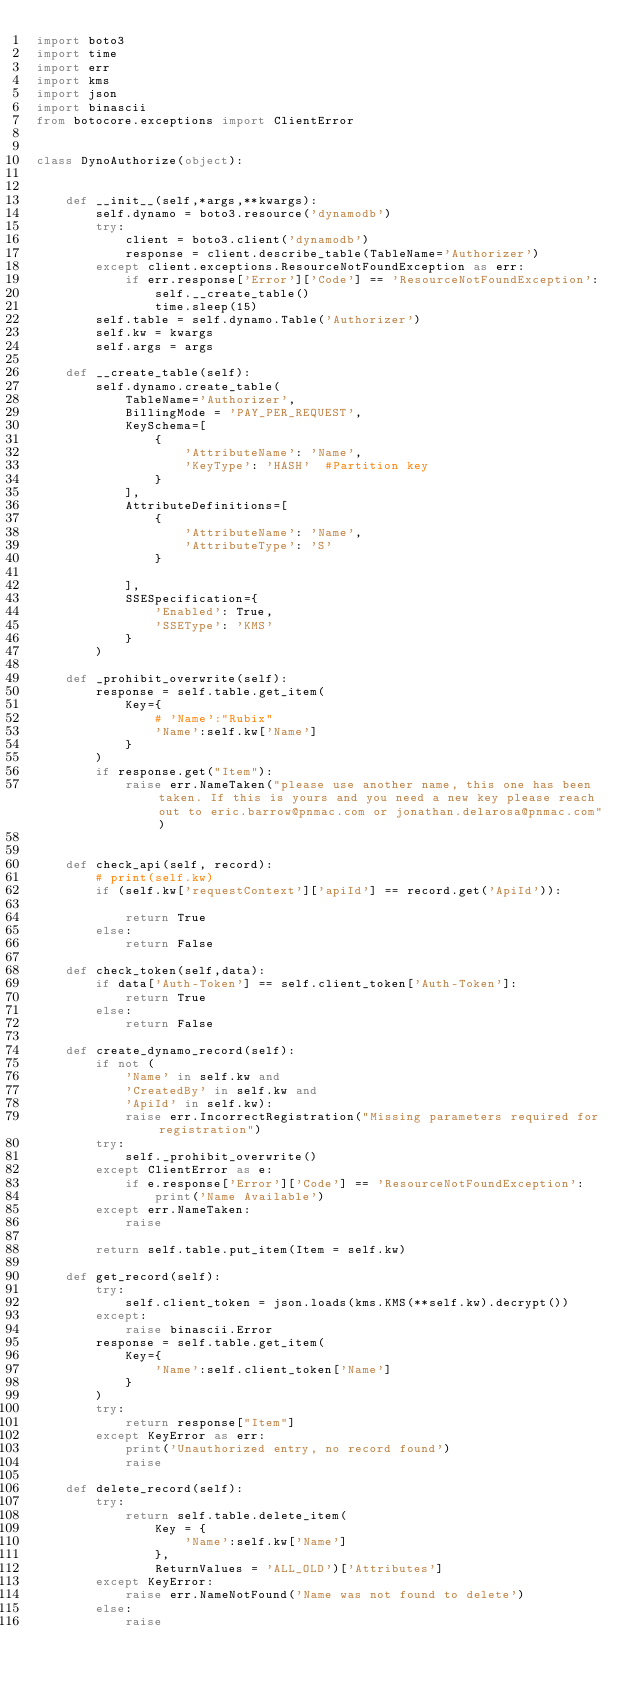Convert code to text. <code><loc_0><loc_0><loc_500><loc_500><_Python_>import boto3
import time
import err
import kms
import json
import binascii
from botocore.exceptions import ClientError


class DynoAuthorize(object):


    def __init__(self,*args,**kwargs):
        self.dynamo = boto3.resource('dynamodb')
        try:
            client = boto3.client('dynamodb')
            response = client.describe_table(TableName='Authorizer')
        except client.exceptions.ResourceNotFoundException as err:
            if err.response['Error']['Code'] == 'ResourceNotFoundException':
                self.__create_table()
                time.sleep(15)
        self.table = self.dynamo.Table('Authorizer')
        self.kw = kwargs
        self.args = args

    def __create_table(self):
        self.dynamo.create_table(
            TableName='Authorizer',
            BillingMode = 'PAY_PER_REQUEST',
            KeySchema=[
                {
                    'AttributeName': 'Name',
                    'KeyType': 'HASH'  #Partition key
                }
            ],
            AttributeDefinitions=[
                {
                    'AttributeName': 'Name',
                    'AttributeType': 'S'
                }

            ],
            SSESpecification={
                'Enabled': True,
                'SSEType': 'KMS'
            }
        )

    def _prohibit_overwrite(self):
        response = self.table.get_item(
            Key={
                # 'Name':"Rubix"
                'Name':self.kw['Name']
            }
        )
        if response.get("Item"):
            raise err.NameTaken("please use another name, this one has been taken. If this is yours and you need a new key please reach out to eric.barrow@pnmac.com or jonathan.delarosa@pnmac.com")


    def check_api(self, record):
        # print(self.kw)
        if (self.kw['requestContext']['apiId'] == record.get('ApiId')):

            return True
        else:
            return False

    def check_token(self,data):
        if data['Auth-Token'] == self.client_token['Auth-Token']:
            return True
        else:
            return False

    def create_dynamo_record(self):
        if not (
            'Name' in self.kw and
            'CreatedBy' in self.kw and
            'ApiId' in self.kw):
            raise err.IncorrectRegistration("Missing parameters required for registration")
        try:
            self._prohibit_overwrite()
        except ClientError as e:
            if e.response['Error']['Code'] == 'ResourceNotFoundException':
                print('Name Available')
        except err.NameTaken:
            raise

        return self.table.put_item(Item = self.kw)

    def get_record(self):
        try:
            self.client_token = json.loads(kms.KMS(**self.kw).decrypt())
        except:
            raise binascii.Error
        response = self.table.get_item(
            Key={
                'Name':self.client_token['Name']
            }
        )
        try:
            return response["Item"]
        except KeyError as err:
            print('Unauthorized entry, no record found')
            raise

    def delete_record(self):
        try:
            return self.table.delete_item(
                Key = {
                    'Name':self.kw['Name']
                },
                ReturnValues = 'ALL_OLD')['Attributes']
        except KeyError:
            raise err.NameNotFound('Name was not found to delete')
        else:
            raise

</code> 